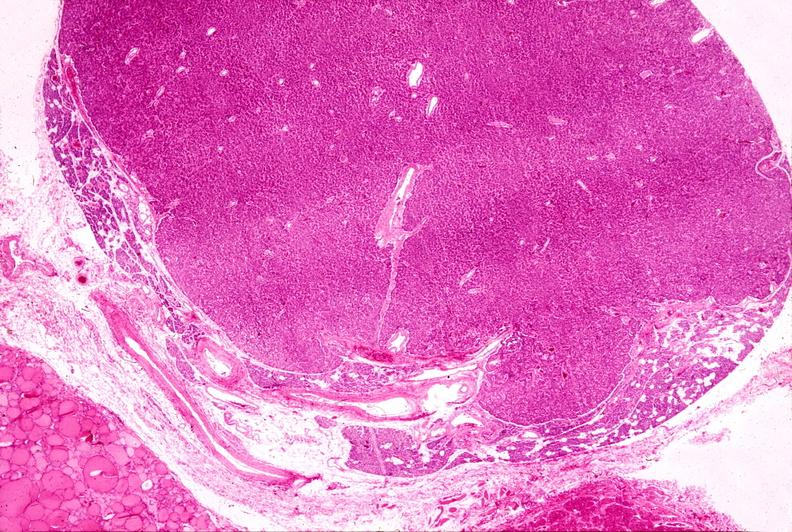what is present?
Answer the question using a single word or phrase. Endocrine 